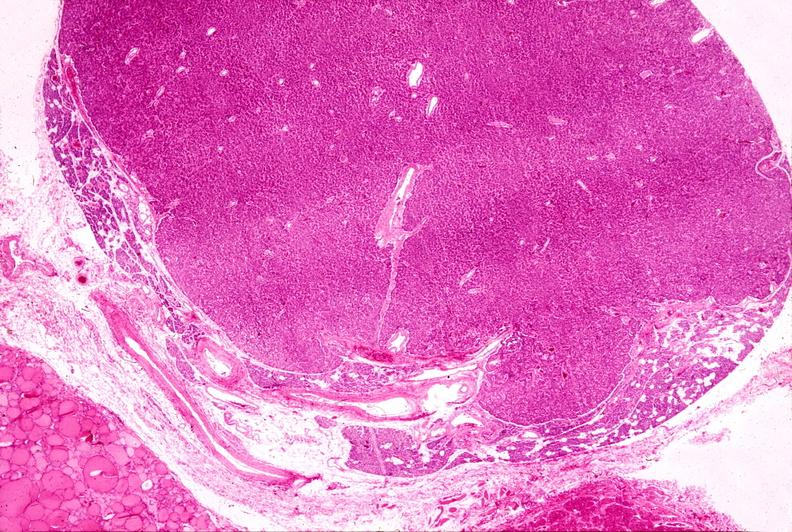what is present?
Answer the question using a single word or phrase. Endocrine 